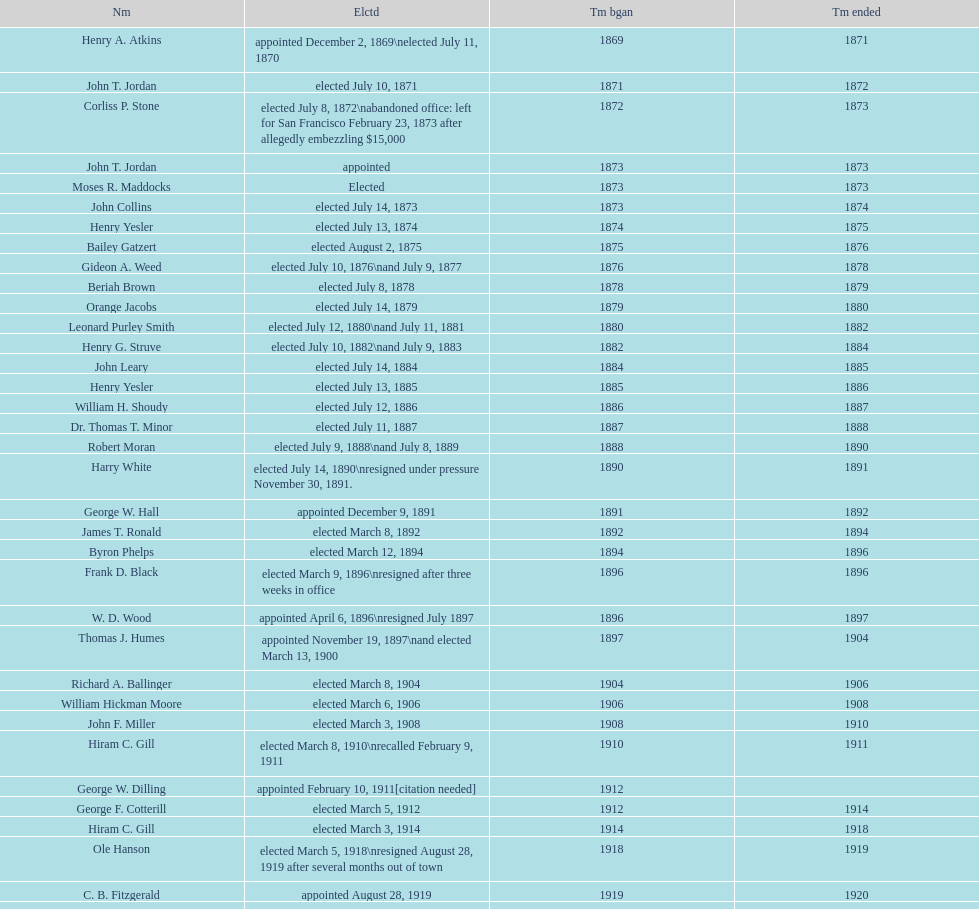Who was the mayor before jordan? Henry A. Atkins. Can you parse all the data within this table? {'header': ['Nm', 'Elctd', 'Tm bgan', 'Tm ended'], 'rows': [['Henry A. Atkins', 'appointed December 2, 1869\\nelected July 11, 1870', '1869', '1871'], ['John T. Jordan', 'elected July 10, 1871', '1871', '1872'], ['Corliss P. Stone', 'elected July 8, 1872\\nabandoned office: left for San Francisco February 23, 1873 after allegedly embezzling $15,000', '1872', '1873'], ['John T. Jordan', 'appointed', '1873', '1873'], ['Moses R. Maddocks', 'Elected', '1873', '1873'], ['John Collins', 'elected July 14, 1873', '1873', '1874'], ['Henry Yesler', 'elected July 13, 1874', '1874', '1875'], ['Bailey Gatzert', 'elected August 2, 1875', '1875', '1876'], ['Gideon A. Weed', 'elected July 10, 1876\\nand July 9, 1877', '1876', '1878'], ['Beriah Brown', 'elected July 8, 1878', '1878', '1879'], ['Orange Jacobs', 'elected July 14, 1879', '1879', '1880'], ['Leonard Purley Smith', 'elected July 12, 1880\\nand July 11, 1881', '1880', '1882'], ['Henry G. Struve', 'elected July 10, 1882\\nand July 9, 1883', '1882', '1884'], ['John Leary', 'elected July 14, 1884', '1884', '1885'], ['Henry Yesler', 'elected July 13, 1885', '1885', '1886'], ['William H. Shoudy', 'elected July 12, 1886', '1886', '1887'], ['Dr. Thomas T. Minor', 'elected July 11, 1887', '1887', '1888'], ['Robert Moran', 'elected July 9, 1888\\nand July 8, 1889', '1888', '1890'], ['Harry White', 'elected July 14, 1890\\nresigned under pressure November 30, 1891.', '1890', '1891'], ['George W. Hall', 'appointed December 9, 1891', '1891', '1892'], ['James T. Ronald', 'elected March 8, 1892', '1892', '1894'], ['Byron Phelps', 'elected March 12, 1894', '1894', '1896'], ['Frank D. Black', 'elected March 9, 1896\\nresigned after three weeks in office', '1896', '1896'], ['W. D. Wood', 'appointed April 6, 1896\\nresigned July 1897', '1896', '1897'], ['Thomas J. Humes', 'appointed November 19, 1897\\nand elected March 13, 1900', '1897', '1904'], ['Richard A. Ballinger', 'elected March 8, 1904', '1904', '1906'], ['William Hickman Moore', 'elected March 6, 1906', '1906', '1908'], ['John F. Miller', 'elected March 3, 1908', '1908', '1910'], ['Hiram C. Gill', 'elected March 8, 1910\\nrecalled February 9, 1911', '1910', '1911'], ['George W. Dilling', 'appointed February 10, 1911[citation needed]', '1912', ''], ['George F. Cotterill', 'elected March 5, 1912', '1912', '1914'], ['Hiram C. Gill', 'elected March 3, 1914', '1914', '1918'], ['Ole Hanson', 'elected March 5, 1918\\nresigned August 28, 1919 after several months out of town', '1918', '1919'], ['C. B. Fitzgerald', 'appointed August 28, 1919', '1919', '1920'], ['Hugh M. Caldwell', 'elected March 2, 1920', '1920', '1922'], ['Edwin J. Brown', 'elected May 2, 1922\\nand March 4, 1924', '1922', '1926'], ['Bertha Knight Landes', 'elected March 9, 1926', '1926', '1928'], ['Frank E. Edwards', 'elected March 6, 1928\\nand March 4, 1930\\nrecalled July 13, 1931', '1928', '1931'], ['Robert H. Harlin', 'appointed July 14, 1931', '1931', '1932'], ['John F. Dore', 'elected March 8, 1932', '1932', '1934'], ['Charles L. Smith', 'elected March 6, 1934', '1934', '1936'], ['John F. Dore', 'elected March 3, 1936\\nbecame gravely ill and was relieved of office April 13, 1938, already a lame duck after the 1938 election. He died five days later.', '1936', '1938'], ['Arthur B. Langlie', "elected March 8, 1938\\nappointed to take office early, April 27, 1938, after Dore's death.\\nelected March 5, 1940\\nresigned January 11, 1941, to become Governor of Washington", '1938', '1941'], ['John E. Carroll', 'appointed January 27, 1941', '1941', '1941'], ['Earl Millikin', 'elected March 4, 1941', '1941', '1942'], ['William F. Devin', 'elected March 3, 1942, March 7, 1944, March 5, 1946, and March 2, 1948', '1942', '1952'], ['Allan Pomeroy', 'elected March 4, 1952', '1952', '1956'], ['Gordon S. Clinton', 'elected March 6, 1956\\nand March 8, 1960', '1956', '1964'], ["James d'Orma Braman", 'elected March 10, 1964\\nresigned March 23, 1969, to accept an appointment as an Assistant Secretary in the Department of Transportation in the Nixon administration.', '1964', '1969'], ['Floyd C. Miller', 'appointed March 23, 1969', '1969', '1969'], ['Wesley C. Uhlman', 'elected November 4, 1969\\nand November 6, 1973\\nsurvived recall attempt on July 1, 1975', 'December 1, 1969', 'January 1, 1978'], ['Charles Royer', 'elected November 8, 1977, November 3, 1981, and November 5, 1985', 'January 1, 1978', 'January 1, 1990'], ['Norman B. Rice', 'elected November 7, 1989', 'January 1, 1990', 'January 1, 1998'], ['Paul Schell', 'elected November 4, 1997', 'January 1, 1998', 'January 1, 2002'], ['Gregory J. Nickels', 'elected November 6, 2001\\nand November 8, 2005', 'January 1, 2002', 'January 1, 2010'], ['Michael McGinn', 'elected November 3, 2009', 'January 1, 2010', 'January 1, 2014'], ['Ed Murray', 'elected November 5, 2013', 'January 1, 2014', 'present']]} 